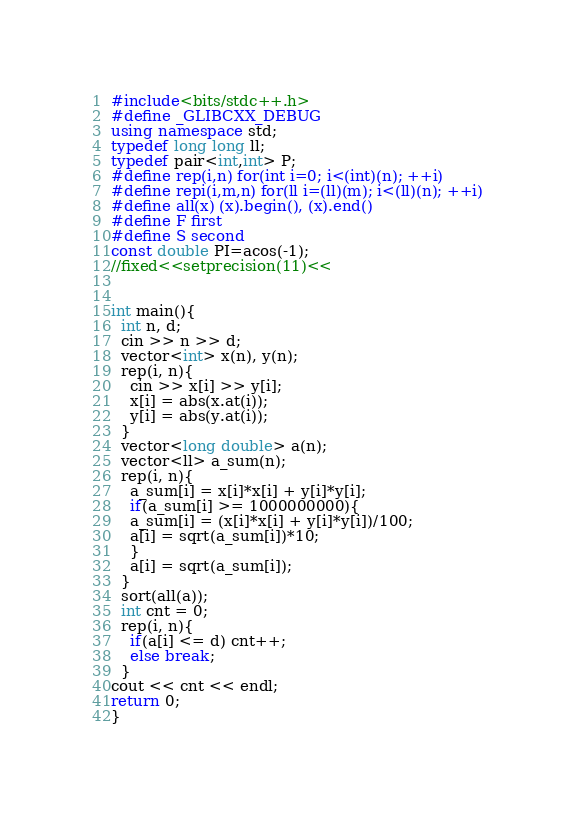Convert code to text. <code><loc_0><loc_0><loc_500><loc_500><_C++_>#include<bits/stdc++.h>
#define _GLIBCXX_DEBUG
using namespace std;
typedef long long ll;
typedef pair<int,int> P;
#define rep(i,n) for(int i=0; i<(int)(n); ++i)
#define repi(i,m,n) for(ll i=(ll)(m); i<(ll)(n); ++i)
#define all(x) (x).begin(), (x).end()
#define F first
#define S second
const double PI=acos(-1);
//fixed<<setprecision(11)<<


int main(){
  int n, d;
  cin >> n >> d;
  vector<int> x(n), y(n);
  rep(i, n){
    cin >> x[i] >> y[i];
    x[i] = abs(x.at(i));
    y[i] = abs(y.at(i));
  }
  vector<long double> a(n);
  vector<ll> a_sum(n);
  rep(i, n){
    a_sum[i] = x[i]*x[i] + y[i]*y[i];
    if(a_sum[i] >= 1000000000){
    a_sum[i] = (x[i]*x[i] + y[i]*y[i])/100;
    a[i] = sqrt(a_sum[i])*10;
    }
    a[i] = sqrt(a_sum[i]);
  }
  sort(all(a));
  int cnt = 0;
  rep(i, n){
    if(a[i] <= d) cnt++;
    else break;
  }
cout << cnt << endl;
return 0;
}</code> 